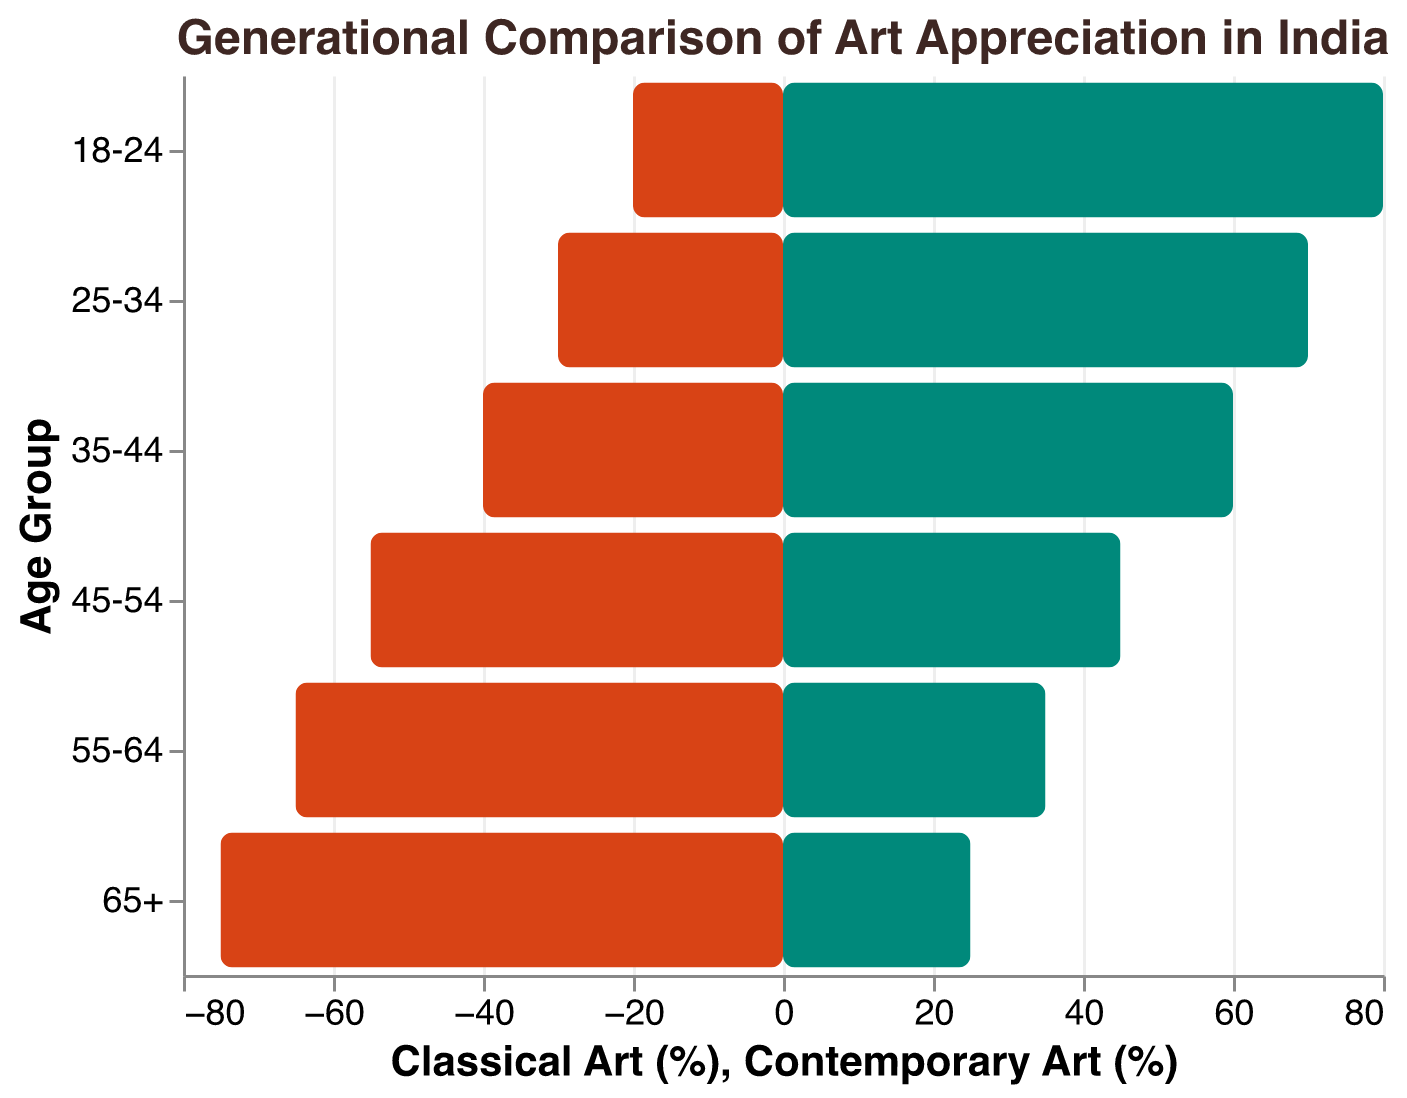What is the title of the figure? The title is typically placed at the top of the figure and is used to describe what the figure represents. In this case, you can read the title directly from the top.
Answer: Generational Comparison of Art Appreciation in India What age group has the highest percentage of appreciation for classical art? To find the highest percentage for classical art, look at the data for all age groups under the 'Classical Art (%)' segment and find the maximum value. This is 75% for the '65+' age group.
Answer: 65+ What is the percentage difference in appreciation for contemporary art between the 18-24 and 65+ age groups? First, identify the percentages of contemporary art appreciation for these groups: 80% for 18-24 and 25% for 65+. The difference is calculated as 80% - 25% which equals 55%.
Answer: 55% How does the preference for contemporary art change as age decreases? By examining the bars for contemporary art from the oldest group to the youngest, you can observe a trend. The percentages increase from 25% in the 65+ group to 80% in the 18-24 group, indicating that contemporary art preference increases as age decreases.
Answer: Increases Which age group has a higher appreciation for contemporary art, 25-34 or 45-54? Compare the contemporary art appreciation percentages for the 25-34 age group (70%) and the 45-54 age group (45%). The 25-34 age group has a higher appreciation.
Answer: 25-34 What is the difference in classical art appreciation between the 35-44 and 55-64 age groups? Identify the classical art appreciation percentages for these groups: 40% for 35-44 and 65% for 55-64. The difference is 65% - 40% = 25%.
Answer: 25% What can be inferred about the overall trend in classical art preferences across age groups? Analyze the classical art percentages from the youngest to the oldest age group. The data shows a decreasing trend in classical art preferences as the age decreases. The preference is highest in the 65+ group and lowest in the 18-24 group.
Answer: Decreasing Which age group shows an equal percentage preference for both classical and contemporary art? None of the age groups have an equal percentage preference for classical and contemporary art. Review each group’s data, and you will see that preferences always differ in favor of one art type over the other.
Answer: None What is the median percentage of appreciation for classical art across all age groups? To find the median, list the classical art preferences in ascending order: 20%, 30%, 40%, 55%, 65%, 75%. The median value is the average of the 3rd and 4th values: (40% + 55%) / 2 = 47.5%.
Answer: 47.5% 